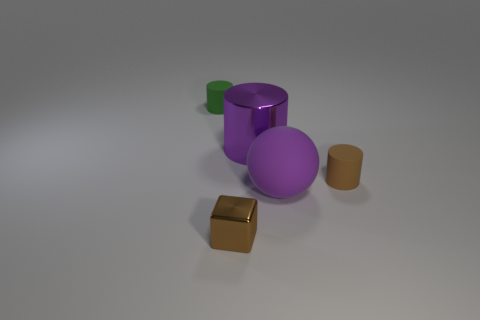The other rubber object that is the same shape as the green rubber thing is what color?
Provide a short and direct response. Brown. Is there any other thing that is the same shape as the tiny green object?
Make the answer very short. Yes. There is a metal object that is in front of the purple rubber sphere; is its color the same as the shiny cylinder?
Your response must be concise. No. What size is the purple object that is the same shape as the green object?
Make the answer very short. Large. What number of big purple blocks have the same material as the large purple cylinder?
Your response must be concise. 0. Are there any small green objects that are in front of the brown rubber cylinder that is right of the ball that is on the right side of the tiny green thing?
Provide a short and direct response. No. What is the shape of the green matte object?
Offer a very short reply. Cylinder. Do the small object in front of the large matte sphere and the tiny object that is to the left of the brown metal cube have the same material?
Provide a short and direct response. No. What number of matte objects have the same color as the tiny block?
Your answer should be very brief. 1. There is a tiny object that is both on the left side of the big cylinder and on the right side of the green rubber cylinder; what shape is it?
Offer a very short reply. Cube. 